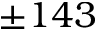Convert formula to latex. <formula><loc_0><loc_0><loc_500><loc_500>\pm 1 4 3</formula> 